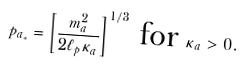Convert formula to latex. <formula><loc_0><loc_0><loc_500><loc_500>p _ { a _ { * } } = \left [ \frac { m _ { a } ^ { 2 } } { 2 \ell _ { p } \kappa _ { a } } \right ] ^ { 1 / 3 } \text { for } \kappa _ { a } > 0 .</formula> 